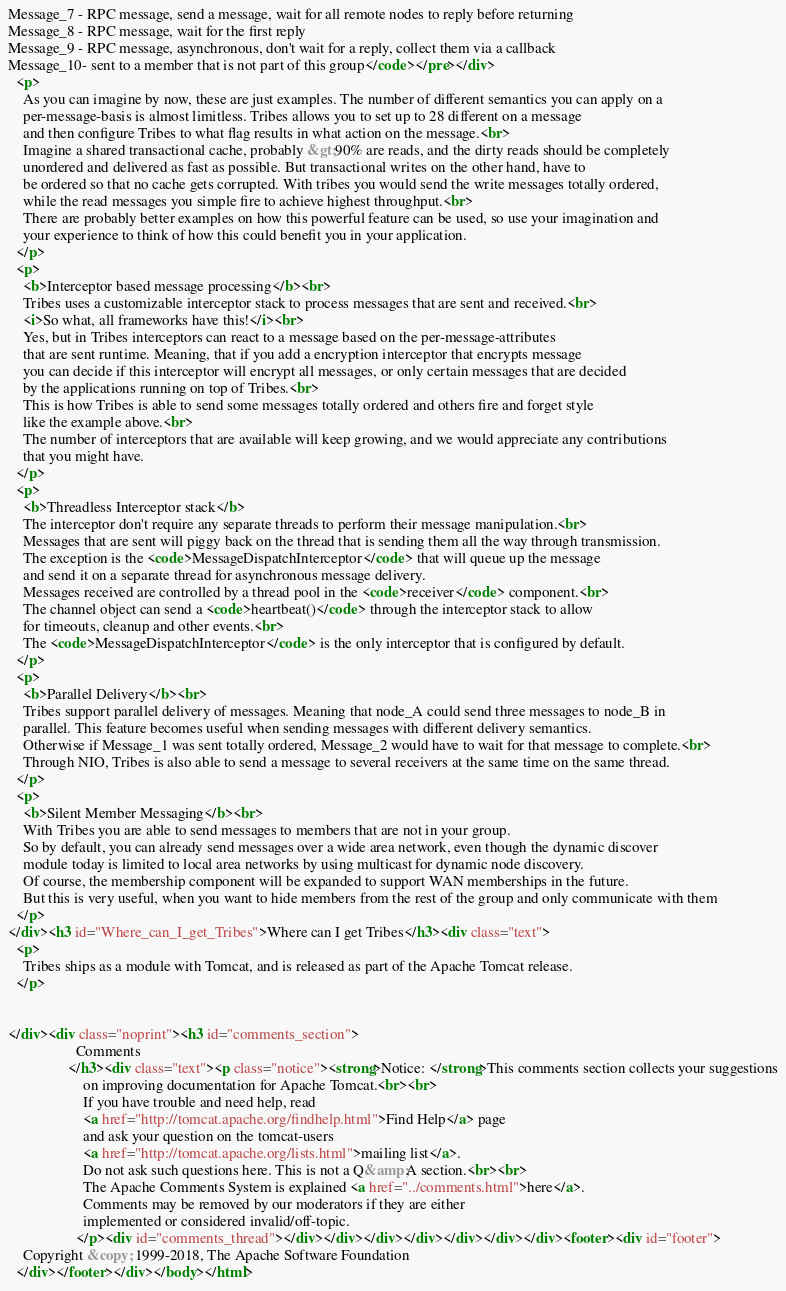<code> <loc_0><loc_0><loc_500><loc_500><_HTML_>Message_7 - RPC message, send a message, wait for all remote nodes to reply before returning
Message_8 - RPC message, wait for the first reply
Message_9 - RPC message, asynchronous, don't wait for a reply, collect them via a callback
Message_10- sent to a member that is not part of this group</code></pre></div>
  <p>
    As you can imagine by now, these are just examples. The number of different semantics you can apply on a
    per-message-basis is almost limitless. Tribes allows you to set up to 28 different on a message
    and then configure Tribes to what flag results in what action on the message.<br>
    Imagine a shared transactional cache, probably &gt;90% are reads, and the dirty reads should be completely
    unordered and delivered as fast as possible. But transactional writes on the other hand, have to
    be ordered so that no cache gets corrupted. With tribes you would send the write messages totally ordered,
    while the read messages you simple fire to achieve highest throughput.<br>
    There are probably better examples on how this powerful feature can be used, so use your imagination and
    your experience to think of how this could benefit you in your application.
  </p>
  <p>
    <b>Interceptor based message processing</b><br>
    Tribes uses a customizable interceptor stack to process messages that are sent and received.<br>
    <i>So what, all frameworks have this!</i><br>
    Yes, but in Tribes interceptors can react to a message based on the per-message-attributes
    that are sent runtime. Meaning, that if you add a encryption interceptor that encrypts message
    you can decide if this interceptor will encrypt all messages, or only certain messages that are decided
    by the applications running on top of Tribes.<br>
    This is how Tribes is able to send some messages totally ordered and others fire and forget style
    like the example above.<br>
    The number of interceptors that are available will keep growing, and we would appreciate any contributions
    that you might have.
  </p>
  <p>
    <b>Threadless Interceptor stack</b>
    The interceptor don't require any separate threads to perform their message manipulation.<br>
    Messages that are sent will piggy back on the thread that is sending them all the way through transmission.
    The exception is the <code>MessageDispatchInterceptor</code> that will queue up the message
    and send it on a separate thread for asynchronous message delivery.
    Messages received are controlled by a thread pool in the <code>receiver</code> component.<br>
    The channel object can send a <code>heartbeat()</code> through the interceptor stack to allow
    for timeouts, cleanup and other events.<br>
    The <code>MessageDispatchInterceptor</code> is the only interceptor that is configured by default.
  </p>
  <p>
    <b>Parallel Delivery</b><br>
    Tribes support parallel delivery of messages. Meaning that node_A could send three messages to node_B in
    parallel. This feature becomes useful when sending messages with different delivery semantics.
    Otherwise if Message_1 was sent totally ordered, Message_2 would have to wait for that message to complete.<br>
    Through NIO, Tribes is also able to send a message to several receivers at the same time on the same thread.
  </p>
  <p>
    <b>Silent Member Messaging</b><br>
    With Tribes you are able to send messages to members that are not in your group.
    So by default, you can already send messages over a wide area network, even though the dynamic discover
    module today is limited to local area networks by using multicast for dynamic node discovery.
    Of course, the membership component will be expanded to support WAN memberships in the future.
    But this is very useful, when you want to hide members from the rest of the group and only communicate with them
  </p>
</div><h3 id="Where_can_I_get_Tribes">Where can I get Tribes</h3><div class="text">
  <p>
    Tribes ships as a module with Tomcat, and is released as part of the Apache Tomcat release.
  </p>


</div><div class="noprint"><h3 id="comments_section">
                  Comments
                </h3><div class="text"><p class="notice"><strong>Notice: </strong>This comments section collects your suggestions
                    on improving documentation for Apache Tomcat.<br><br>
                    If you have trouble and need help, read
                    <a href="http://tomcat.apache.org/findhelp.html">Find Help</a> page
                    and ask your question on the tomcat-users
                    <a href="http://tomcat.apache.org/lists.html">mailing list</a>.
                    Do not ask such questions here. This is not a Q&amp;A section.<br><br>
                    The Apache Comments System is explained <a href="../comments.html">here</a>.
                    Comments may be removed by our moderators if they are either
                    implemented or considered invalid/off-topic.
                  </p><div id="comments_thread"></div></div></div></div></div></div></div><footer><div id="footer">
    Copyright &copy; 1999-2018, The Apache Software Foundation
  </div></footer></div></body></html></code> 